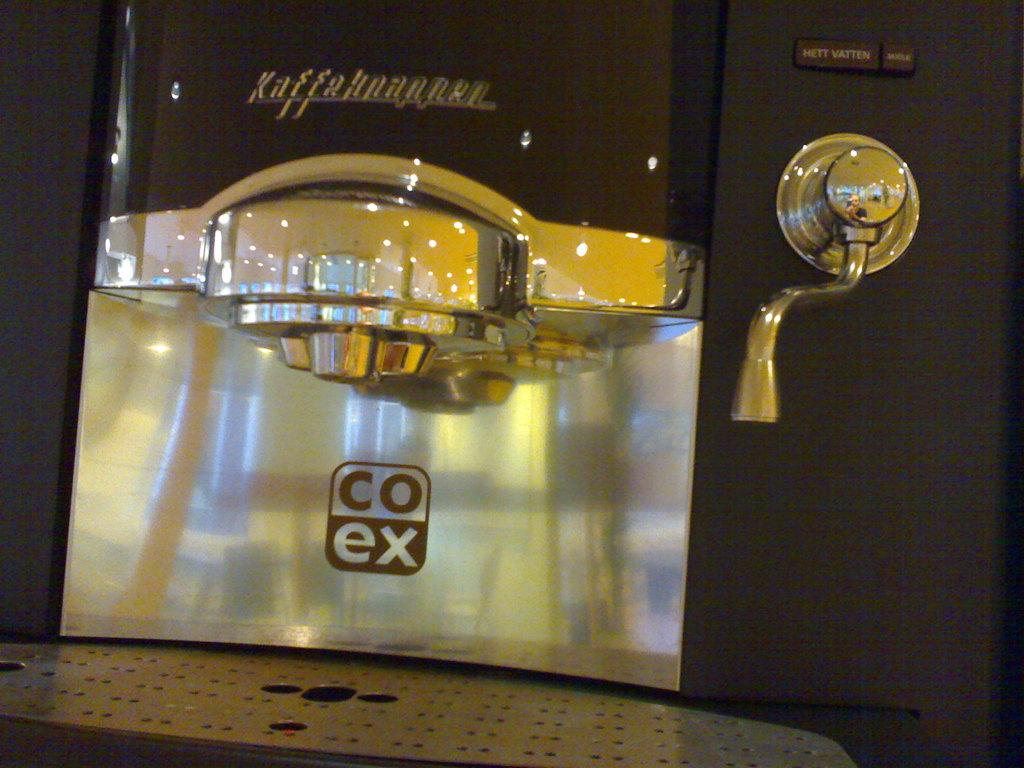<image>
Summarize the visual content of the image. A clean and shiny coffee machine has co ex labeled on it. 